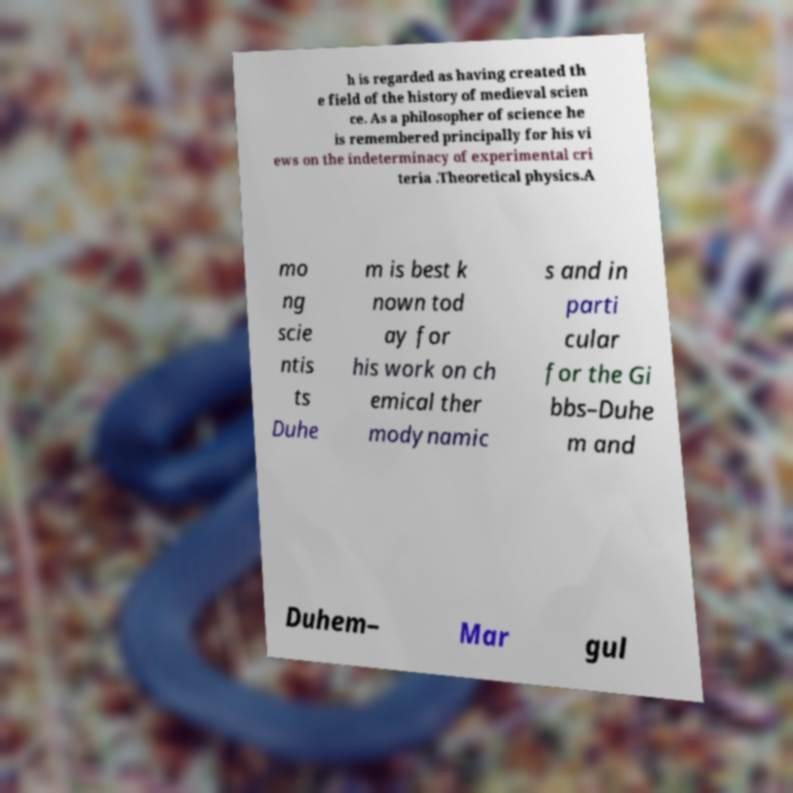Could you extract and type out the text from this image? h is regarded as having created th e field of the history of medieval scien ce. As a philosopher of science he is remembered principally for his vi ews on the indeterminacy of experimental cri teria .Theoretical physics.A mo ng scie ntis ts Duhe m is best k nown tod ay for his work on ch emical ther modynamic s and in parti cular for the Gi bbs–Duhe m and Duhem– Mar gul 